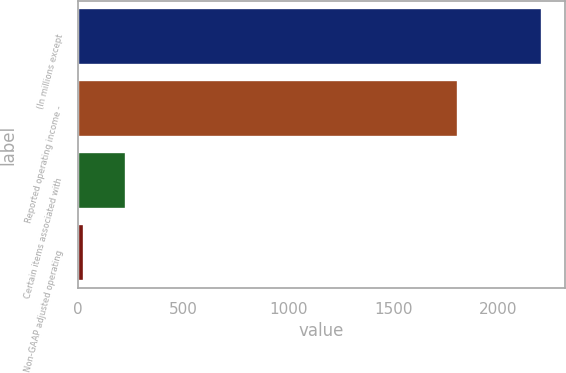<chart> <loc_0><loc_0><loc_500><loc_500><bar_chart><fcel>(In millions except<fcel>Reported operating income -<fcel>Certain items associated with<fcel>Non-GAAP adjusted operating<nl><fcel>2204.4<fcel>1807<fcel>227.7<fcel>29<nl></chart> 